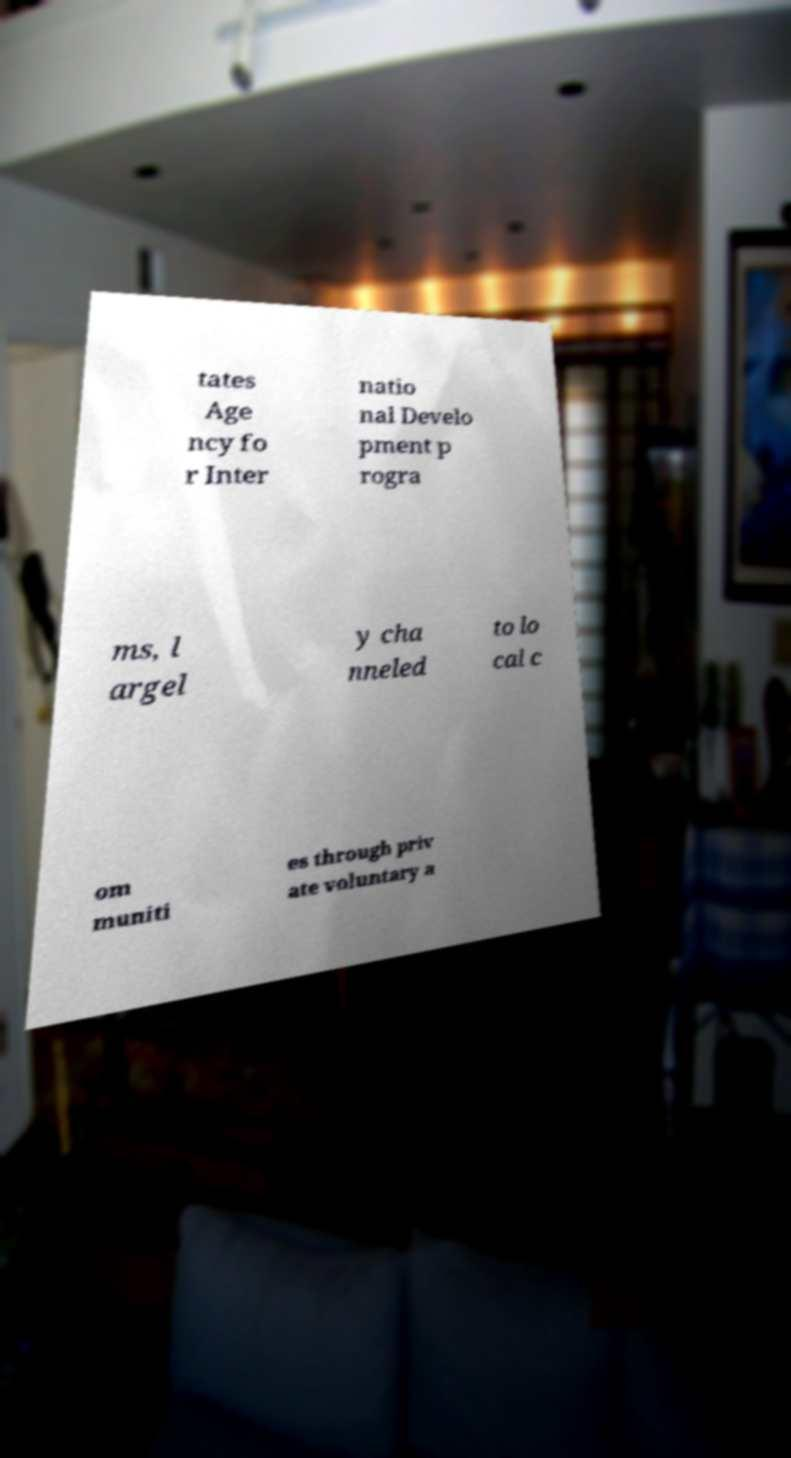Could you assist in decoding the text presented in this image and type it out clearly? tates Age ncy fo r Inter natio nal Develo pment p rogra ms, l argel y cha nneled to lo cal c om muniti es through priv ate voluntary a 